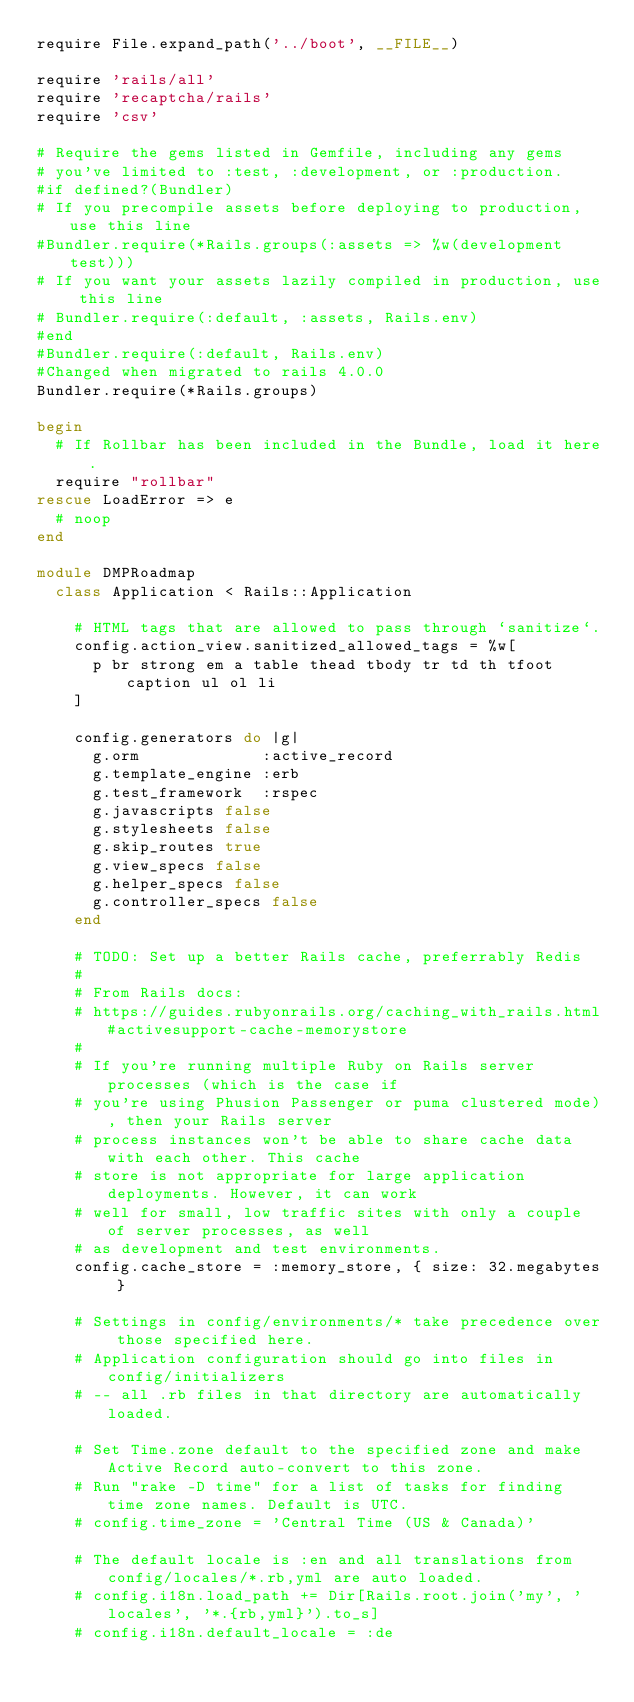<code> <loc_0><loc_0><loc_500><loc_500><_Ruby_>require File.expand_path('../boot', __FILE__)

require 'rails/all'
require 'recaptcha/rails'
require 'csv'

# Require the gems listed in Gemfile, including any gems
# you've limited to :test, :development, or :production.
#if defined?(Bundler)
# If you precompile assets before deploying to production, use this line
#Bundler.require(*Rails.groups(:assets => %w(development test)))
# If you want your assets lazily compiled in production, use this line
# Bundler.require(:default, :assets, Rails.env)
#end
#Bundler.require(:default, Rails.env)
#Changed when migrated to rails 4.0.0
Bundler.require(*Rails.groups)

begin
  # If Rollbar has been included in the Bundle, load it here.
  require "rollbar"
rescue LoadError => e
  # noop
end

module DMPRoadmap
  class Application < Rails::Application

    # HTML tags that are allowed to pass through `sanitize`.
    config.action_view.sanitized_allowed_tags = %w[
      p br strong em a table thead tbody tr td th tfoot caption ul ol li
    ]

    config.generators do |g|
      g.orm             :active_record
      g.template_engine :erb
      g.test_framework  :rspec
      g.javascripts false
      g.stylesheets false
      g.skip_routes true
      g.view_specs false
      g.helper_specs false
      g.controller_specs false
    end

    # TODO: Set up a better Rails cache, preferrably Redis
    #
    # From Rails docs:
    # https://guides.rubyonrails.org/caching_with_rails.html#activesupport-cache-memorystore
    #
    # If you're running multiple Ruby on Rails server processes (which is the case if
    # you're using Phusion Passenger or puma clustered mode), then your Rails server
    # process instances won't be able to share cache data with each other. This cache
    # store is not appropriate for large application deployments. However, it can work
    # well for small, low traffic sites with only a couple of server processes, as well
    # as development and test environments.
    config.cache_store = :memory_store, { size: 32.megabytes }

    # Settings in config/environments/* take precedence over those specified here.
    # Application configuration should go into files in config/initializers
    # -- all .rb files in that directory are automatically loaded.

    # Set Time.zone default to the specified zone and make Active Record auto-convert to this zone.
    # Run "rake -D time" for a list of tasks for finding time zone names. Default is UTC.
    # config.time_zone = 'Central Time (US & Canada)'

    # The default locale is :en and all translations from config/locales/*.rb,yml are auto loaded.
    # config.i18n.load_path += Dir[Rails.root.join('my', 'locales', '*.{rb,yml}').to_s]
    # config.i18n.default_locale = :de
</code> 